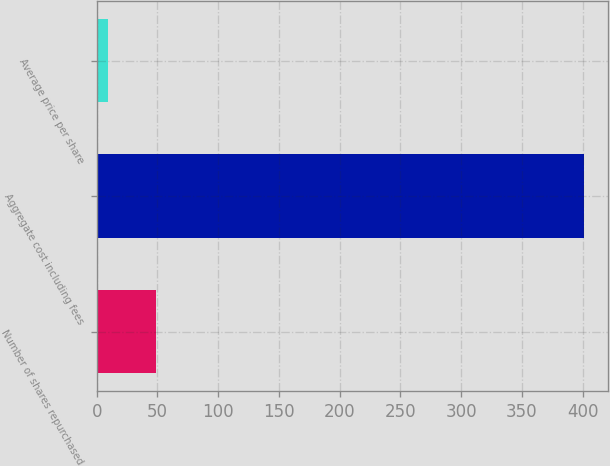<chart> <loc_0><loc_0><loc_500><loc_500><bar_chart><fcel>Number of shares repurchased<fcel>Aggregate cost including fees<fcel>Average price per share<nl><fcel>48.74<fcel>400.8<fcel>9.62<nl></chart> 